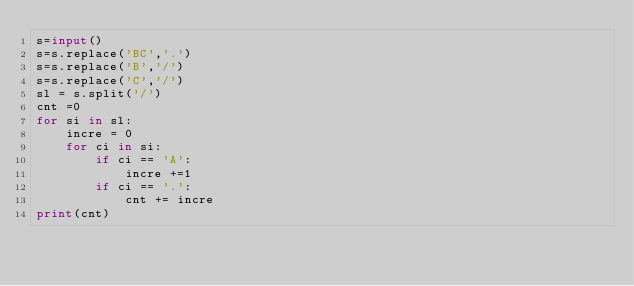Convert code to text. <code><loc_0><loc_0><loc_500><loc_500><_Python_>s=input()
s=s.replace('BC','.')
s=s.replace('B','/')
s=s.replace('C','/')
sl = s.split('/')
cnt =0
for si in sl:
    incre = 0
    for ci in si:
        if ci == 'A':
            incre +=1
        if ci == '.':
            cnt += incre
print(cnt)
</code> 